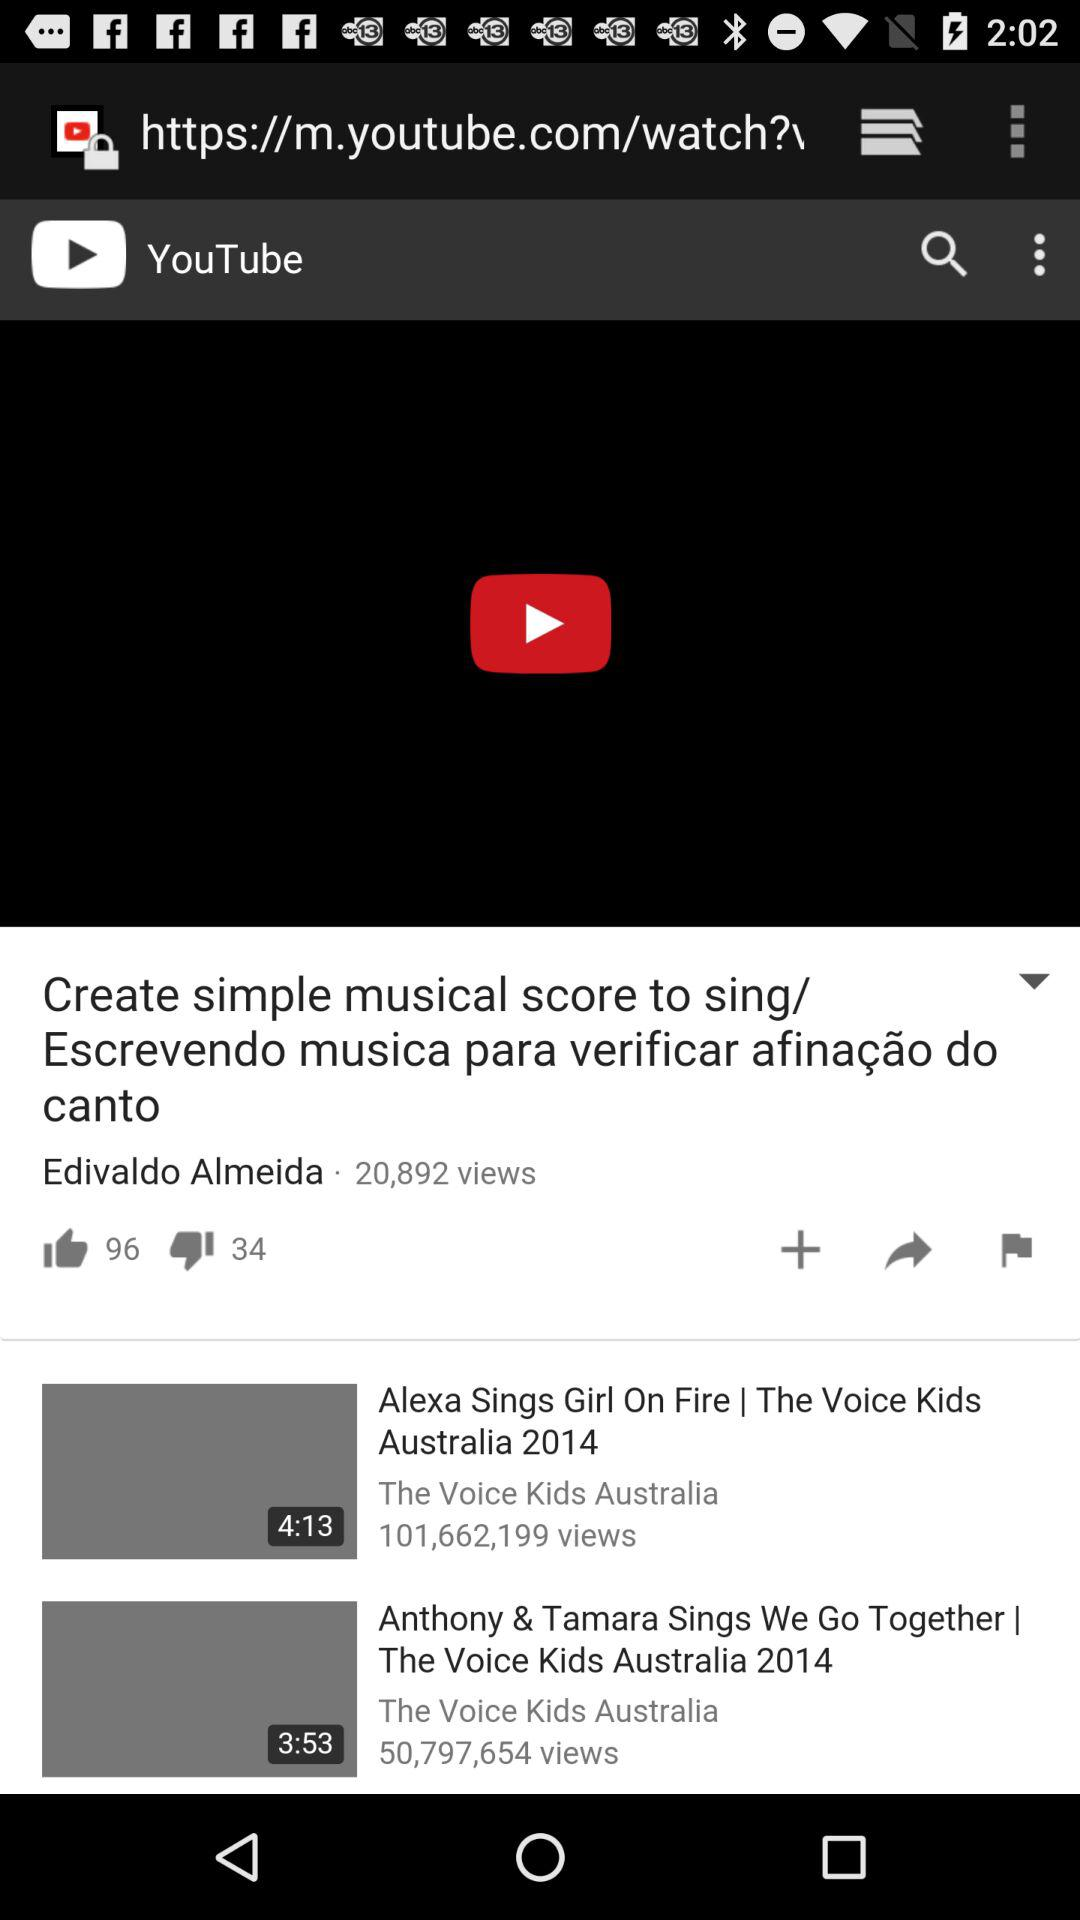Who is the singer of "Create simple musical score to sing/ Escrevendo musica para verificar afinação do canto" song? The singer of "Create simple musical score to sing/ Escrevendo musica para verificar afinação do canto" song is Edivaldo Almeida. 